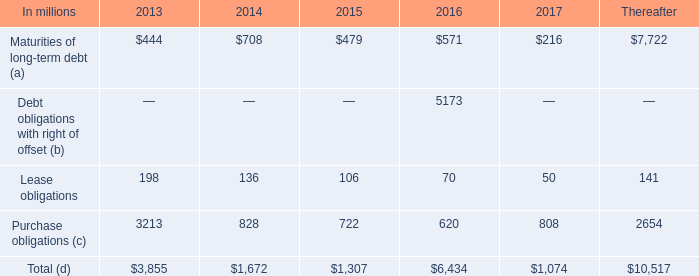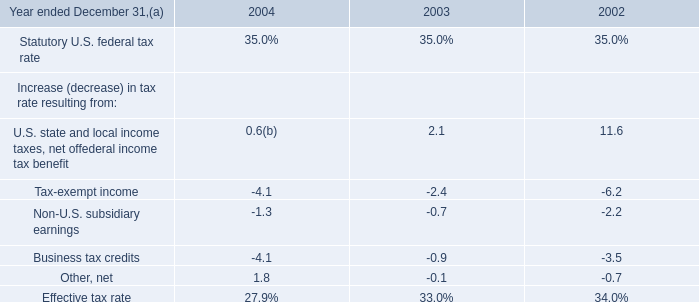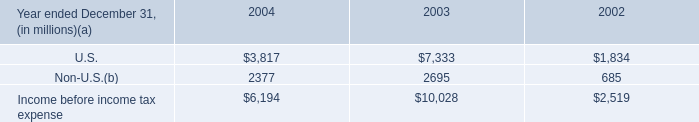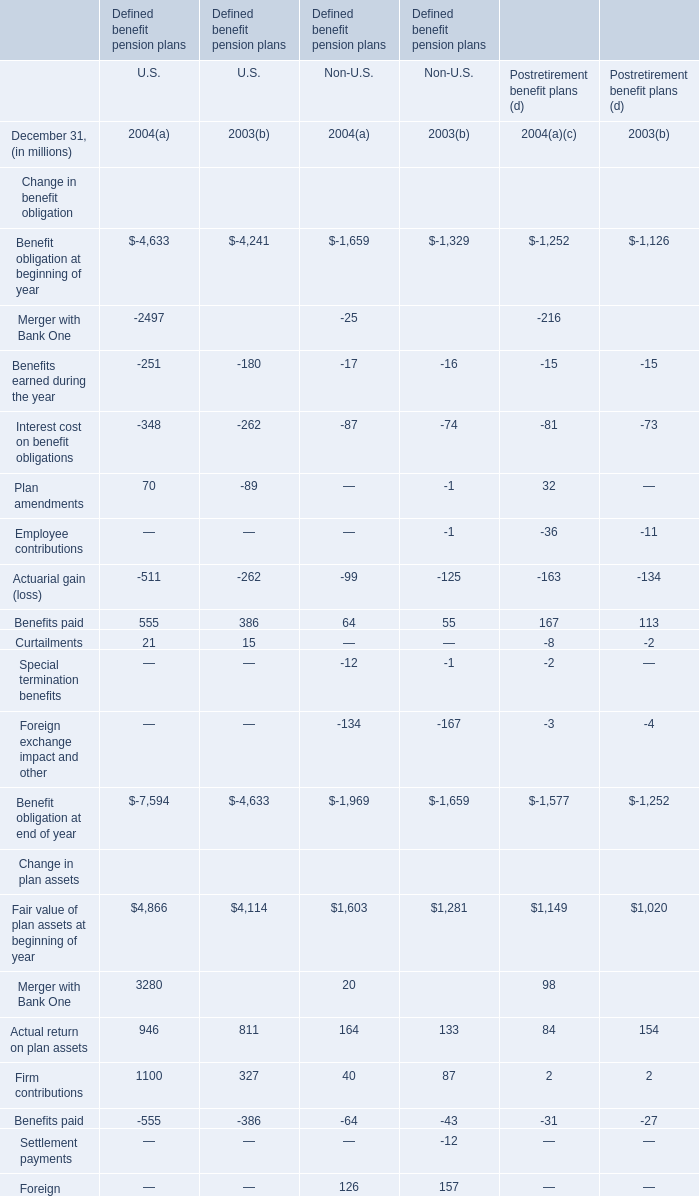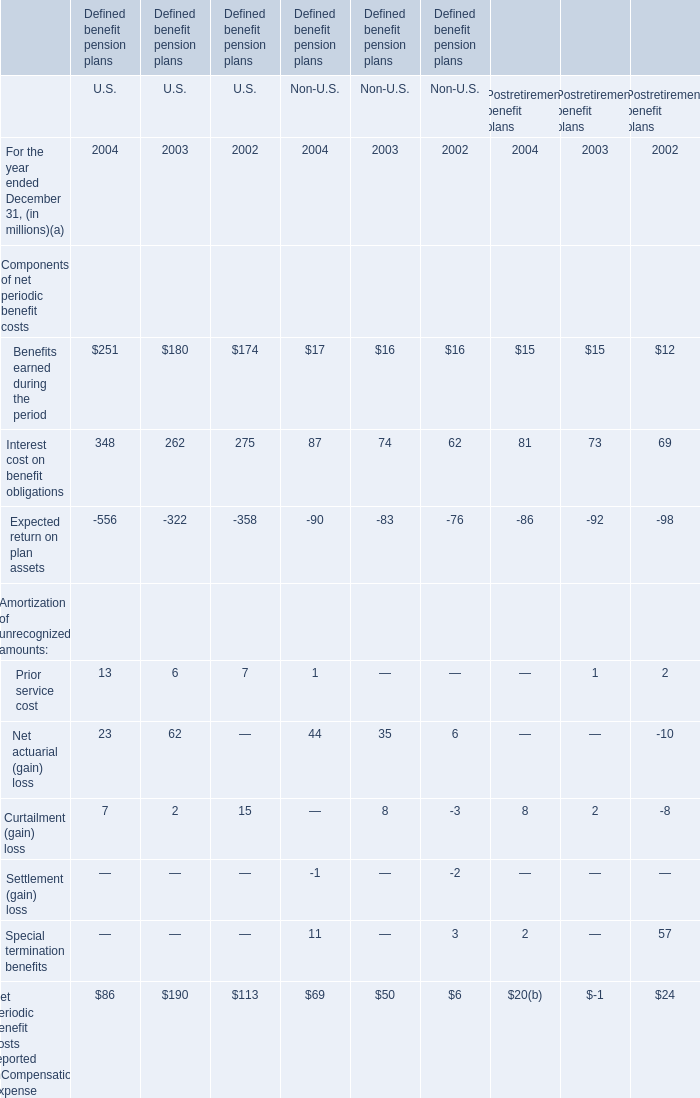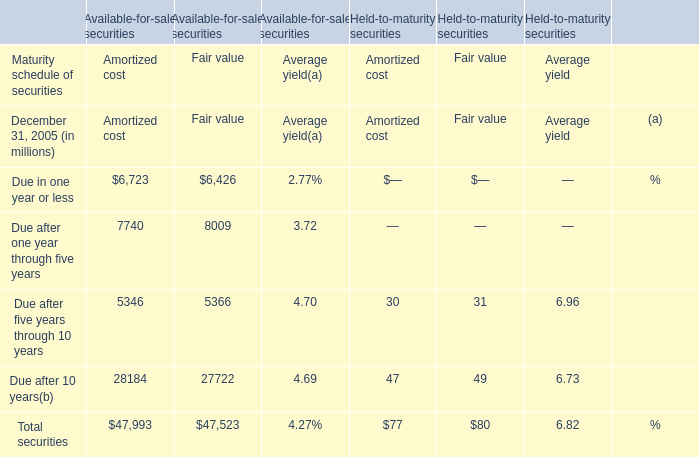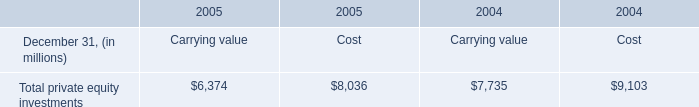What was the average value of Merger with Bank One,Actual return on plan assets, Firm contributions for U.S. in 2004? (in million) 
Computations: (((3280 + 946) + 1100) / 3)
Answer: 1775.33333. 